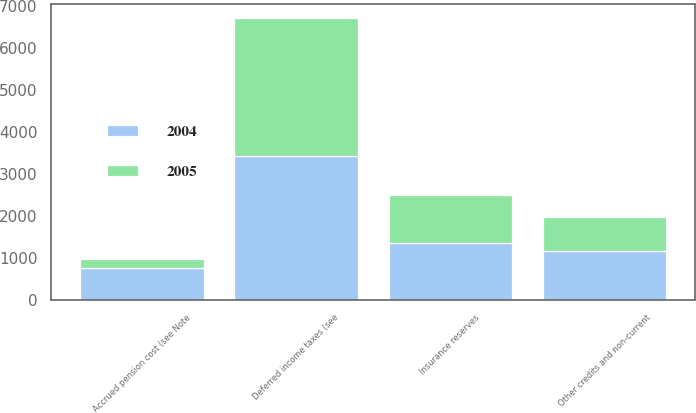Convert chart to OTSL. <chart><loc_0><loc_0><loc_500><loc_500><stacked_bar_chart><ecel><fcel>Deferred income taxes (see<fcel>Insurance reserves<fcel>Accrued pension cost (see Note<fcel>Other credits and non-current<nl><fcel>2004<fcel>3425<fcel>1354<fcel>750<fcel>1153<nl><fcel>2005<fcel>3274<fcel>1136<fcel>221<fcel>819<nl></chart> 